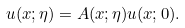Convert formula to latex. <formula><loc_0><loc_0><loc_500><loc_500>u ( x ; \eta ) = A ( x ; \eta ) u ( x ; 0 ) .</formula> 